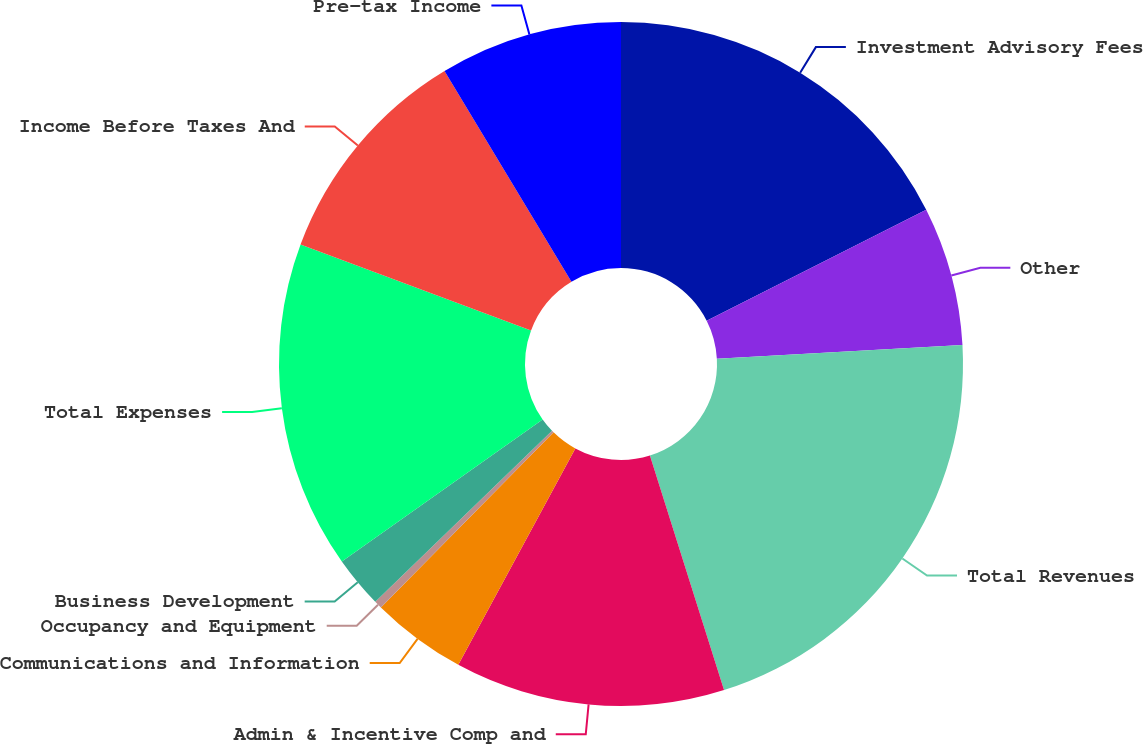<chart> <loc_0><loc_0><loc_500><loc_500><pie_chart><fcel>Investment Advisory Fees<fcel>Other<fcel>Total Revenues<fcel>Admin & Incentive Comp and<fcel>Communications and Information<fcel>Occupancy and Equipment<fcel>Business Development<fcel>Total Expenses<fcel>Income Before Taxes And<fcel>Pre-tax Income<nl><fcel>17.55%<fcel>6.57%<fcel>21.01%<fcel>12.76%<fcel>4.5%<fcel>0.37%<fcel>2.44%<fcel>15.48%<fcel>10.69%<fcel>8.63%<nl></chart> 